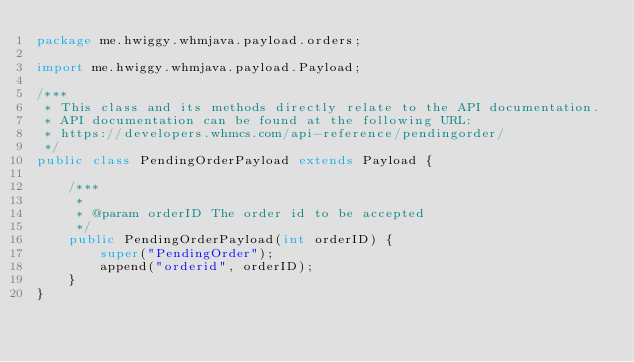<code> <loc_0><loc_0><loc_500><loc_500><_Java_>package me.hwiggy.whmjava.payload.orders;

import me.hwiggy.whmjava.payload.Payload;

/***
 * This class and its methods directly relate to the API documentation.
 * API documentation can be found at the following URL:
 * https://developers.whmcs.com/api-reference/pendingorder/
 */
public class PendingOrderPayload extends Payload {

    /***
     *
     * @param orderID The order id to be accepted
     */
    public PendingOrderPayload(int orderID) {
        super("PendingOrder");
        append("orderid", orderID);
    }
}
</code> 